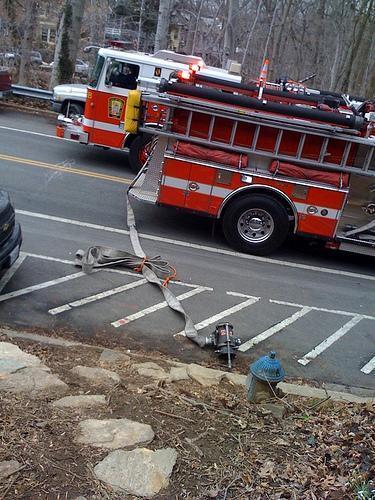How many hoses are there?
Give a very brief answer. 1. How many trucks can be seen?
Give a very brief answer. 2. 